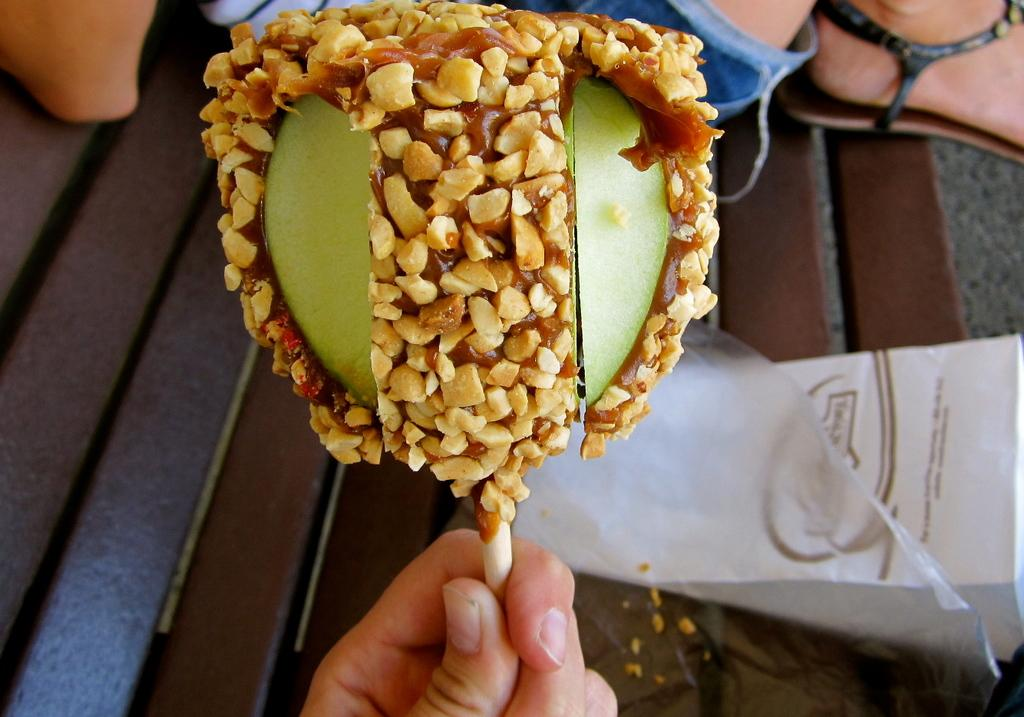What is being held by the person's hand in the foreground of the image? There is a person's hand holding a candy in the foreground of the image. What can be seen in the background of the image? There are covers and a person sitting on a bench in the background of the image. How many lizards are crawling on the candy in the image? There are no lizards present in the image; it only shows a person's hand holding a candy. 